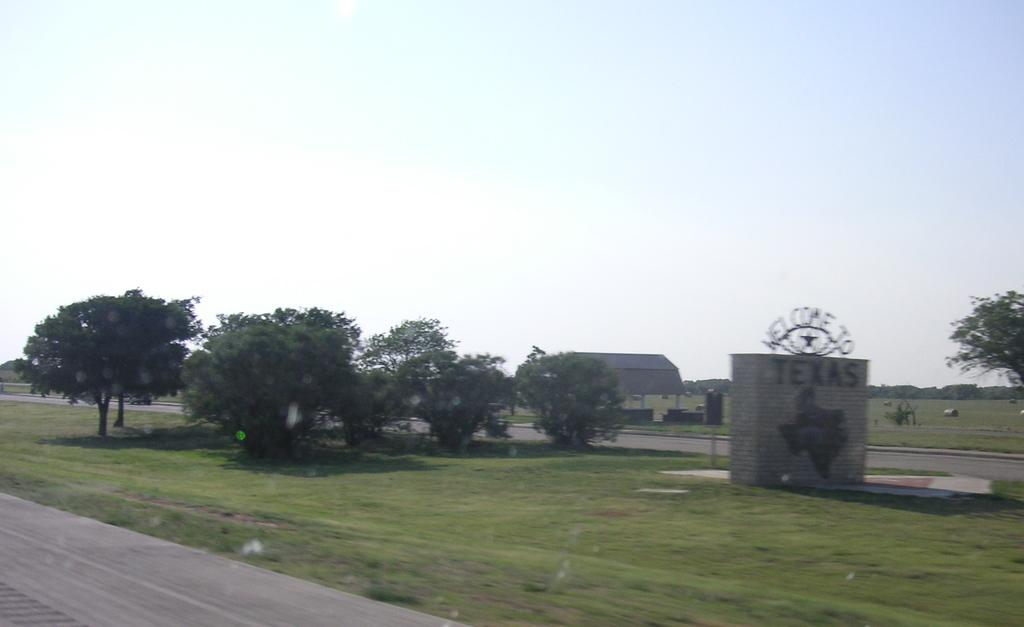What type of vegetation is present in the image? There are trees and grass in the image. What type of structure can be seen in the image? There is a building in the image. What else is present on the ground in the image? There are other objects on the ground in the image. What can be seen in the background of the image? The sky is visible in the background of the image. What type of silk is being used to make the key in the image? There is no key or silk present in the image. How does the beginner interact with the trees in the image? There is no beginner or interaction with the trees mentioned in the image. 